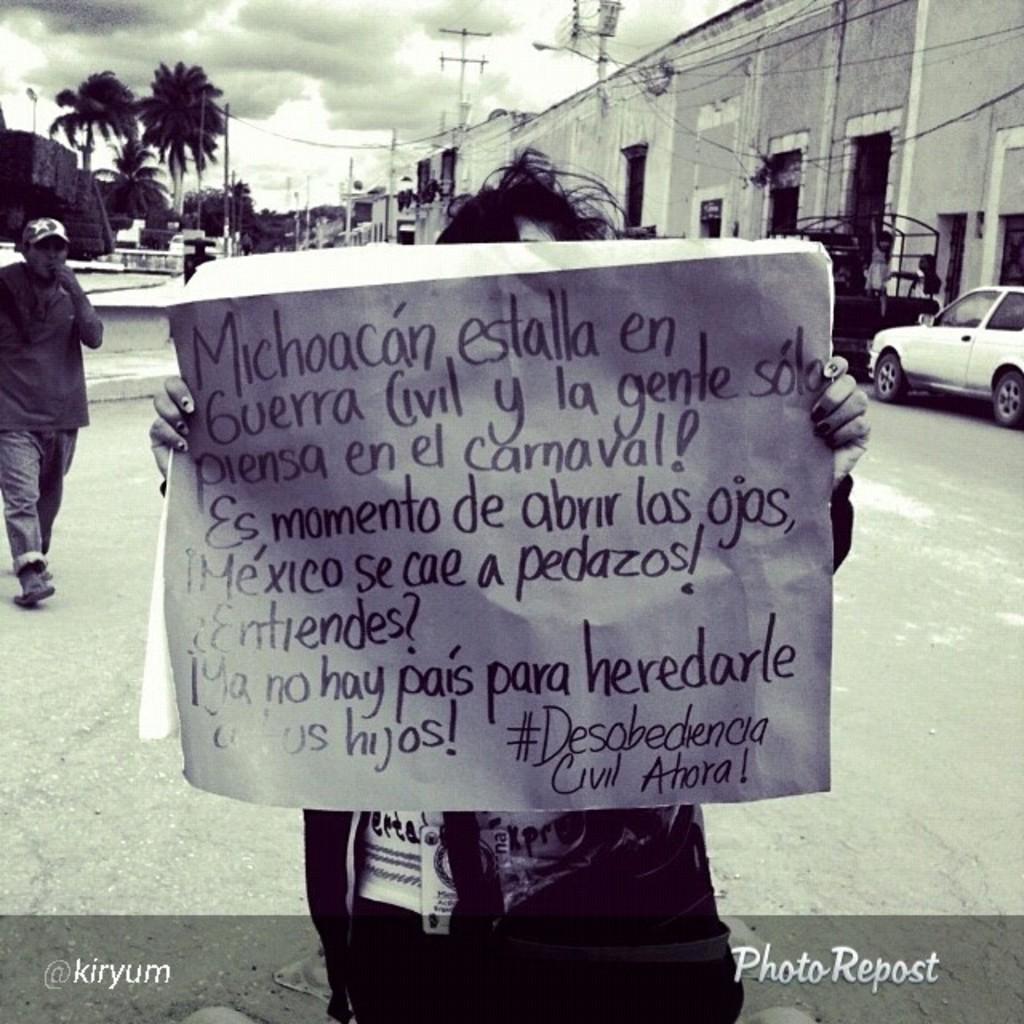Can you describe this image briefly? In this picture we can see a person is holding a chart in the front, we can see some text on the chart, on the left side there is a person walking, in the background we can see buildings, trees and poles, on the right side there is a vehicle, we can see the sky and clouds at the top of the picture, at the bottom there is some text. 